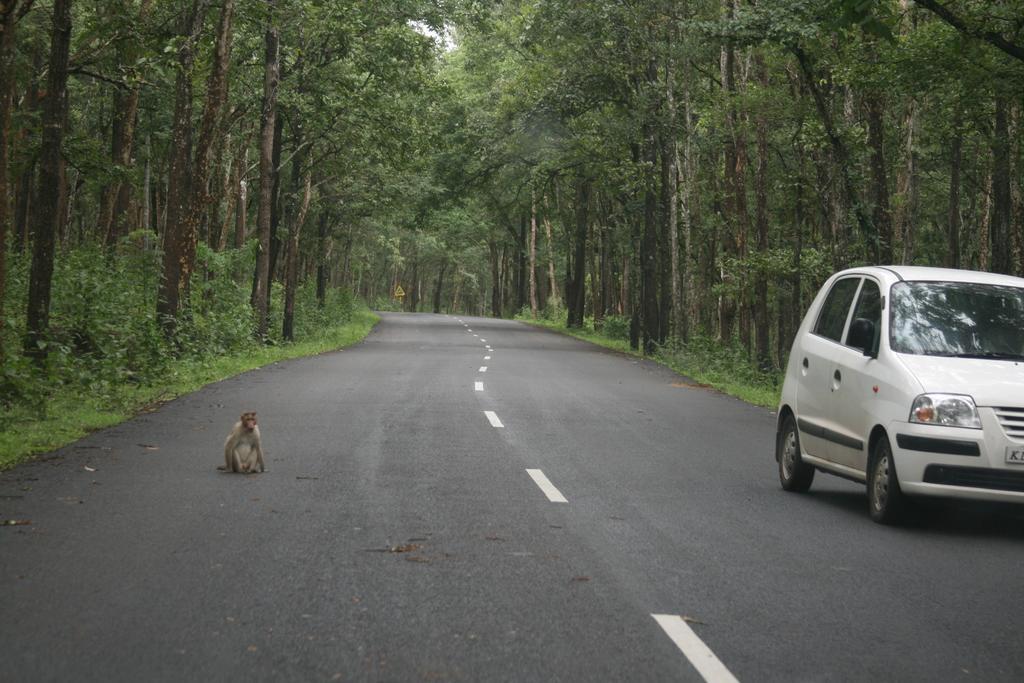How would you summarize this image in a sentence or two? In this picture we can see a car, monkey on the road, signboard, plants and in the background we can see trees. 